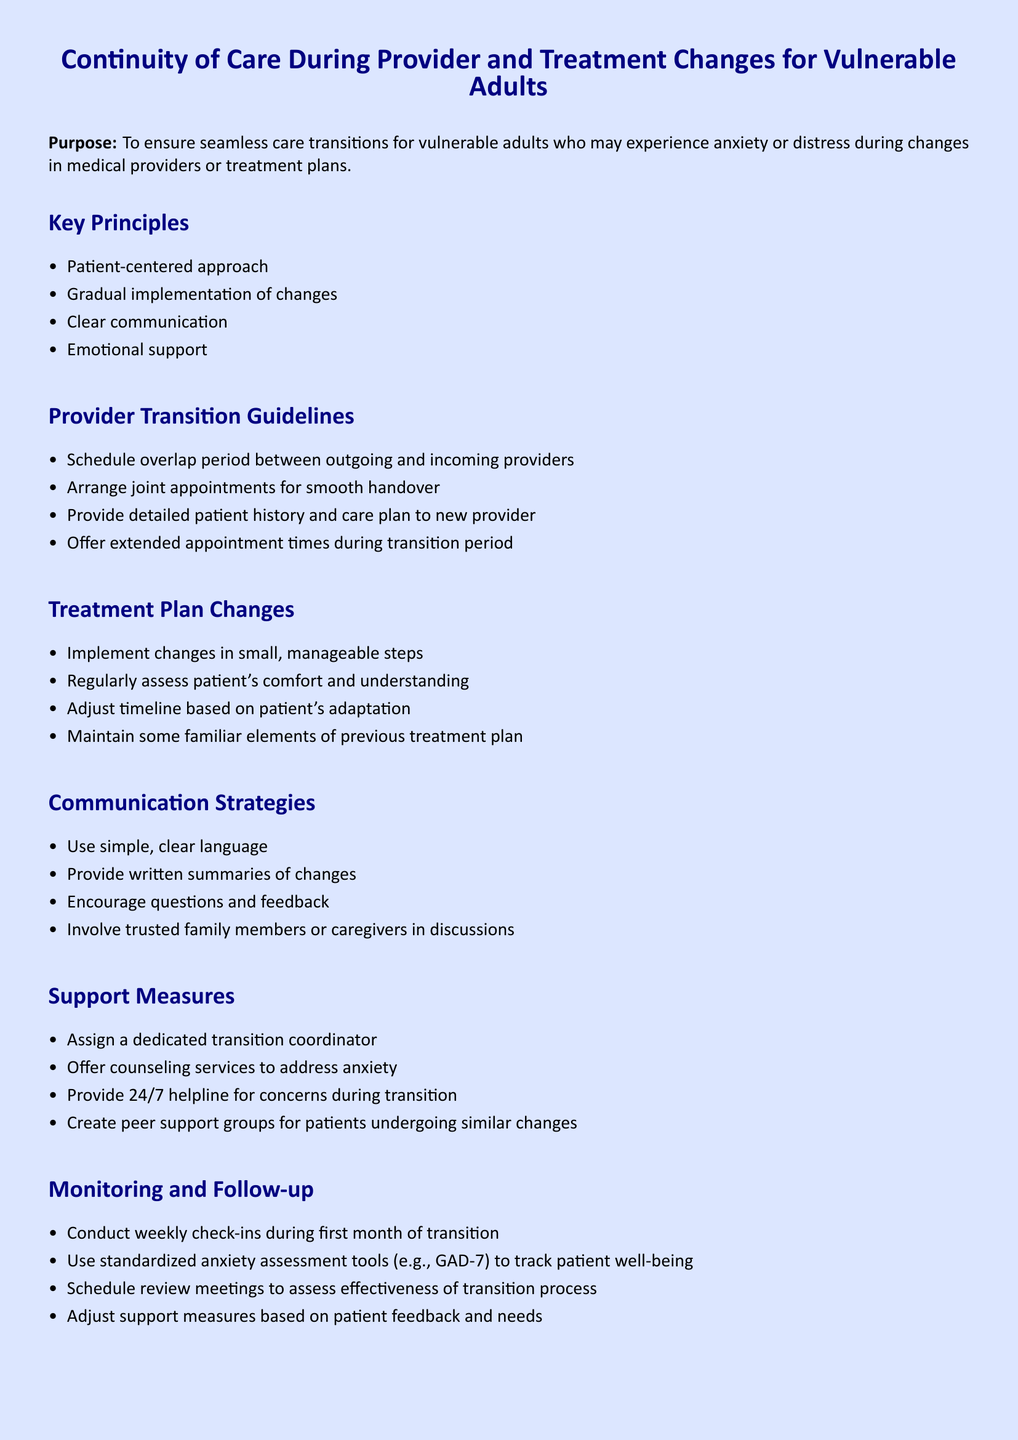What is the purpose of the document? The purpose is to ensure seamless care transitions for vulnerable adults who may experience anxiety or distress during changes in medical providers or treatment plans.
Answer: To ensure seamless care transitions for vulnerable adults What is one key principle mentioned? The document lists several key principles, one of which emphasizes patient-centered care.
Answer: Patient-centered approach How can providers facilitate a smooth transition? Providers can facilitate a smooth transition by arranging joint appointments.
Answer: Arrange joint appointments What is a step mentioned for implementing treatment plan changes? The document states that changes should be implemented in small, manageable steps.
Answer: Small, manageable steps What monitoring tool is recommended for assessing anxiety? The document specifies using standardized anxiety assessment tools, such as GAD-7.
Answer: GAD-7 How often should check-ins be conducted during the first month? The document indicates that check-ins should be conducted weekly during the first month.
Answer: Weekly Who should be involved in discussions about changes? The document recommends involving trusted family members or caregivers in discussions.
Answer: Trusted family members or caregivers What is one support measure provided during transitions? The document lists assigning a dedicated transition coordinator as one of the support measures.
Answer: Dedicated transition coordinator 